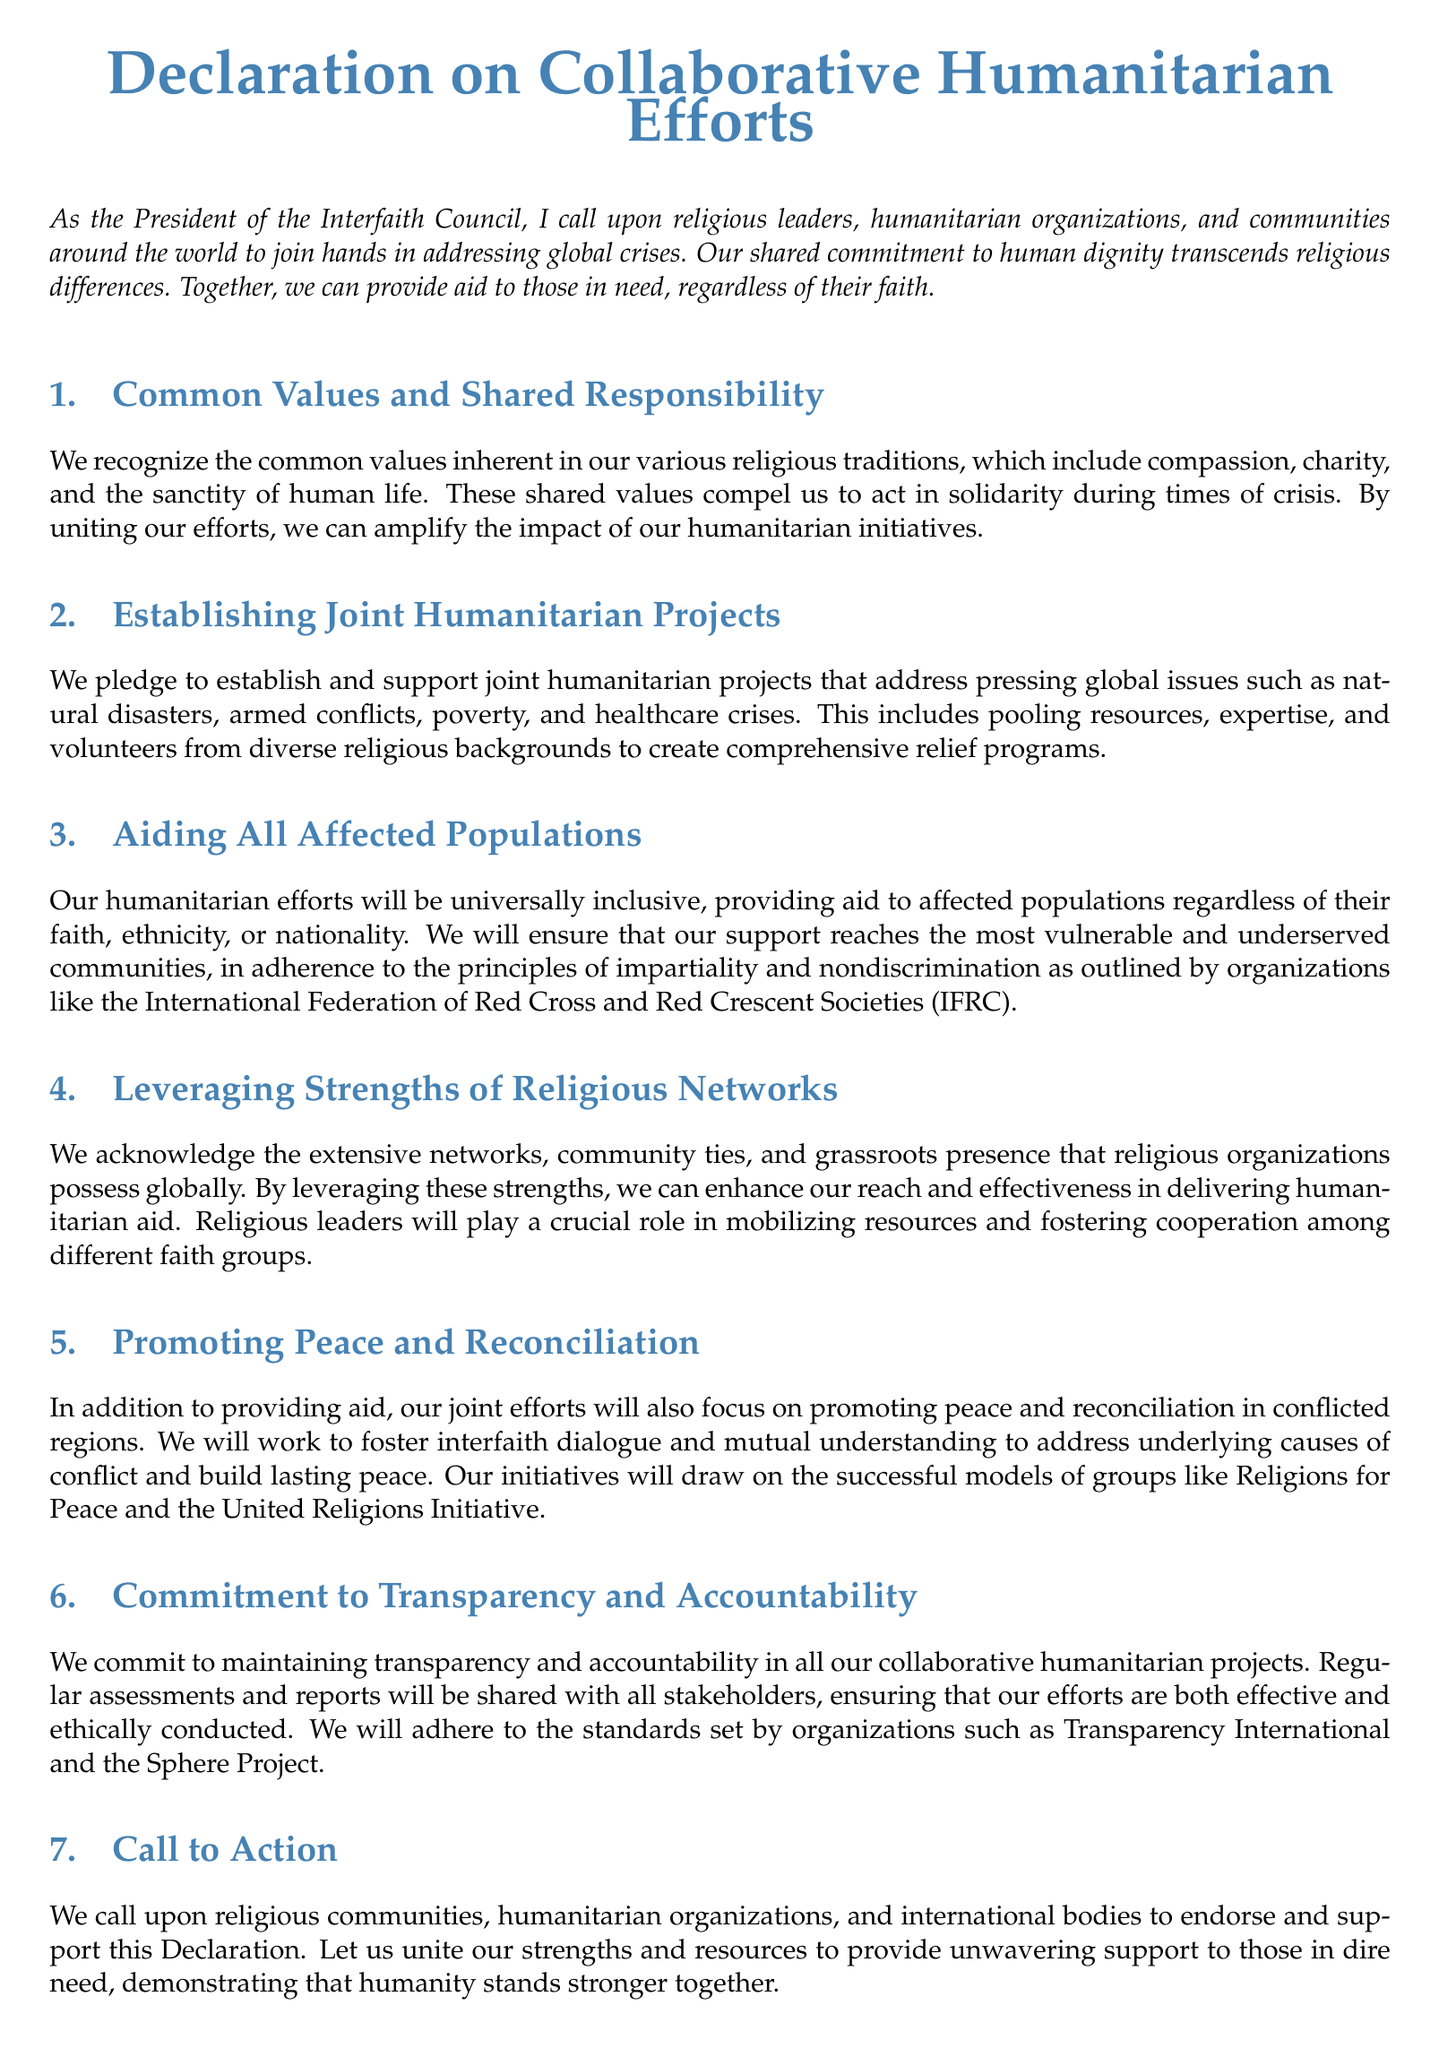What is the title of the document? The title is stated at the beginning of the document as "Declaration on Collaborative Humanitarian Efforts."
Answer: Declaration on Collaborative Humanitarian Efforts Who is calling for the joint humanitarian efforts? The President of the Interfaith Council is the person making this call to action.
Answer: The President of the Interfaith Council What are the shared values mentioned in the document? The document highlights compassion, charity, and the sanctity of human life as common values.
Answer: Compassion, charity, and the sanctity of human life What principle will guide the aid provided to populations? The document emphasizes the principles of impartiality and nondiscrimination for providing aid.
Answer: Impartiality and nondiscrimination Which organizations' standards will be adhered to for transparency and accountability? The document mentions adhering to standards set by Transparency International and the Sphere Project.
Answer: Transparency International and the Sphere Project How will religious leaders contribute to the humanitarian efforts? Religious leaders will play a crucial role in mobilizing resources and fostering cooperation among different faith groups.
Answer: Mobilizing resources and fostering cooperation What is the main focus of the joint efforts besides providing aid? The document states that promoting peace and reconciliation will also be a focus of the joint efforts.
Answer: Promoting peace and reconciliation When will the Declaration be signed? The document indicates that it will be signed on the current day mentioned at the end of the text.
Answer: On this day What type of projects are being pledged in the document? The document pledges to establish and support joint humanitarian projects addressing global issues.
Answer: Joint humanitarian projects 